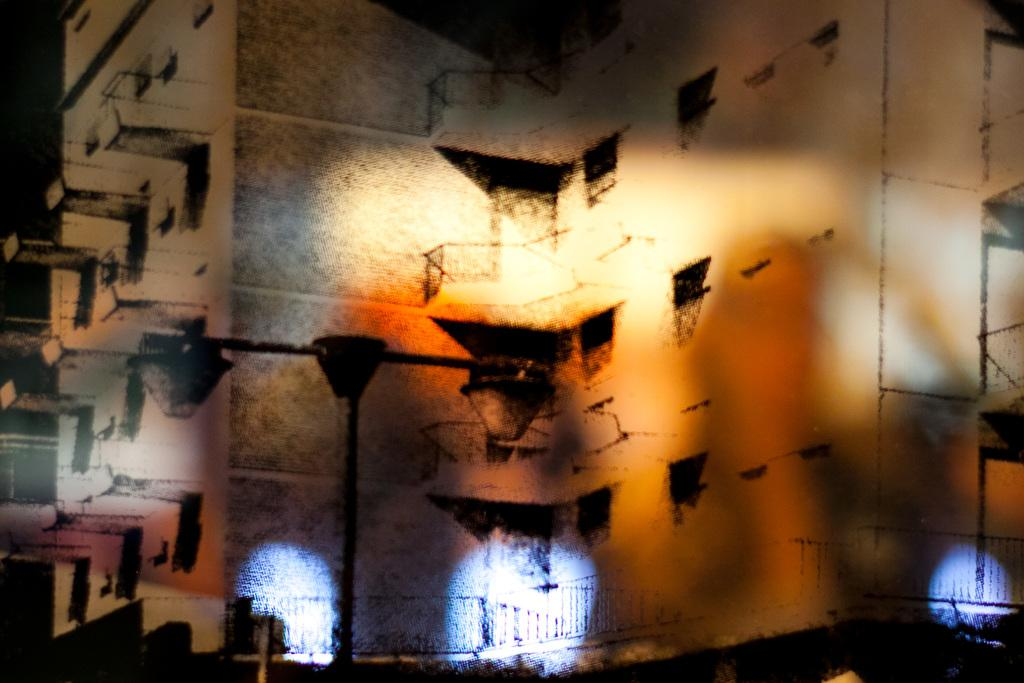What is located in the foreground of the image? There is a pole in the foreground of the image. What structure is visible behind the pole? There is a building behind the pole. Can you describe the lights at the bottom of the image? There are white lights at the bottom of the image. What type of skin condition can be seen on the pole in the image? There is no skin condition present on the pole in the image, as it is an inanimate object. 